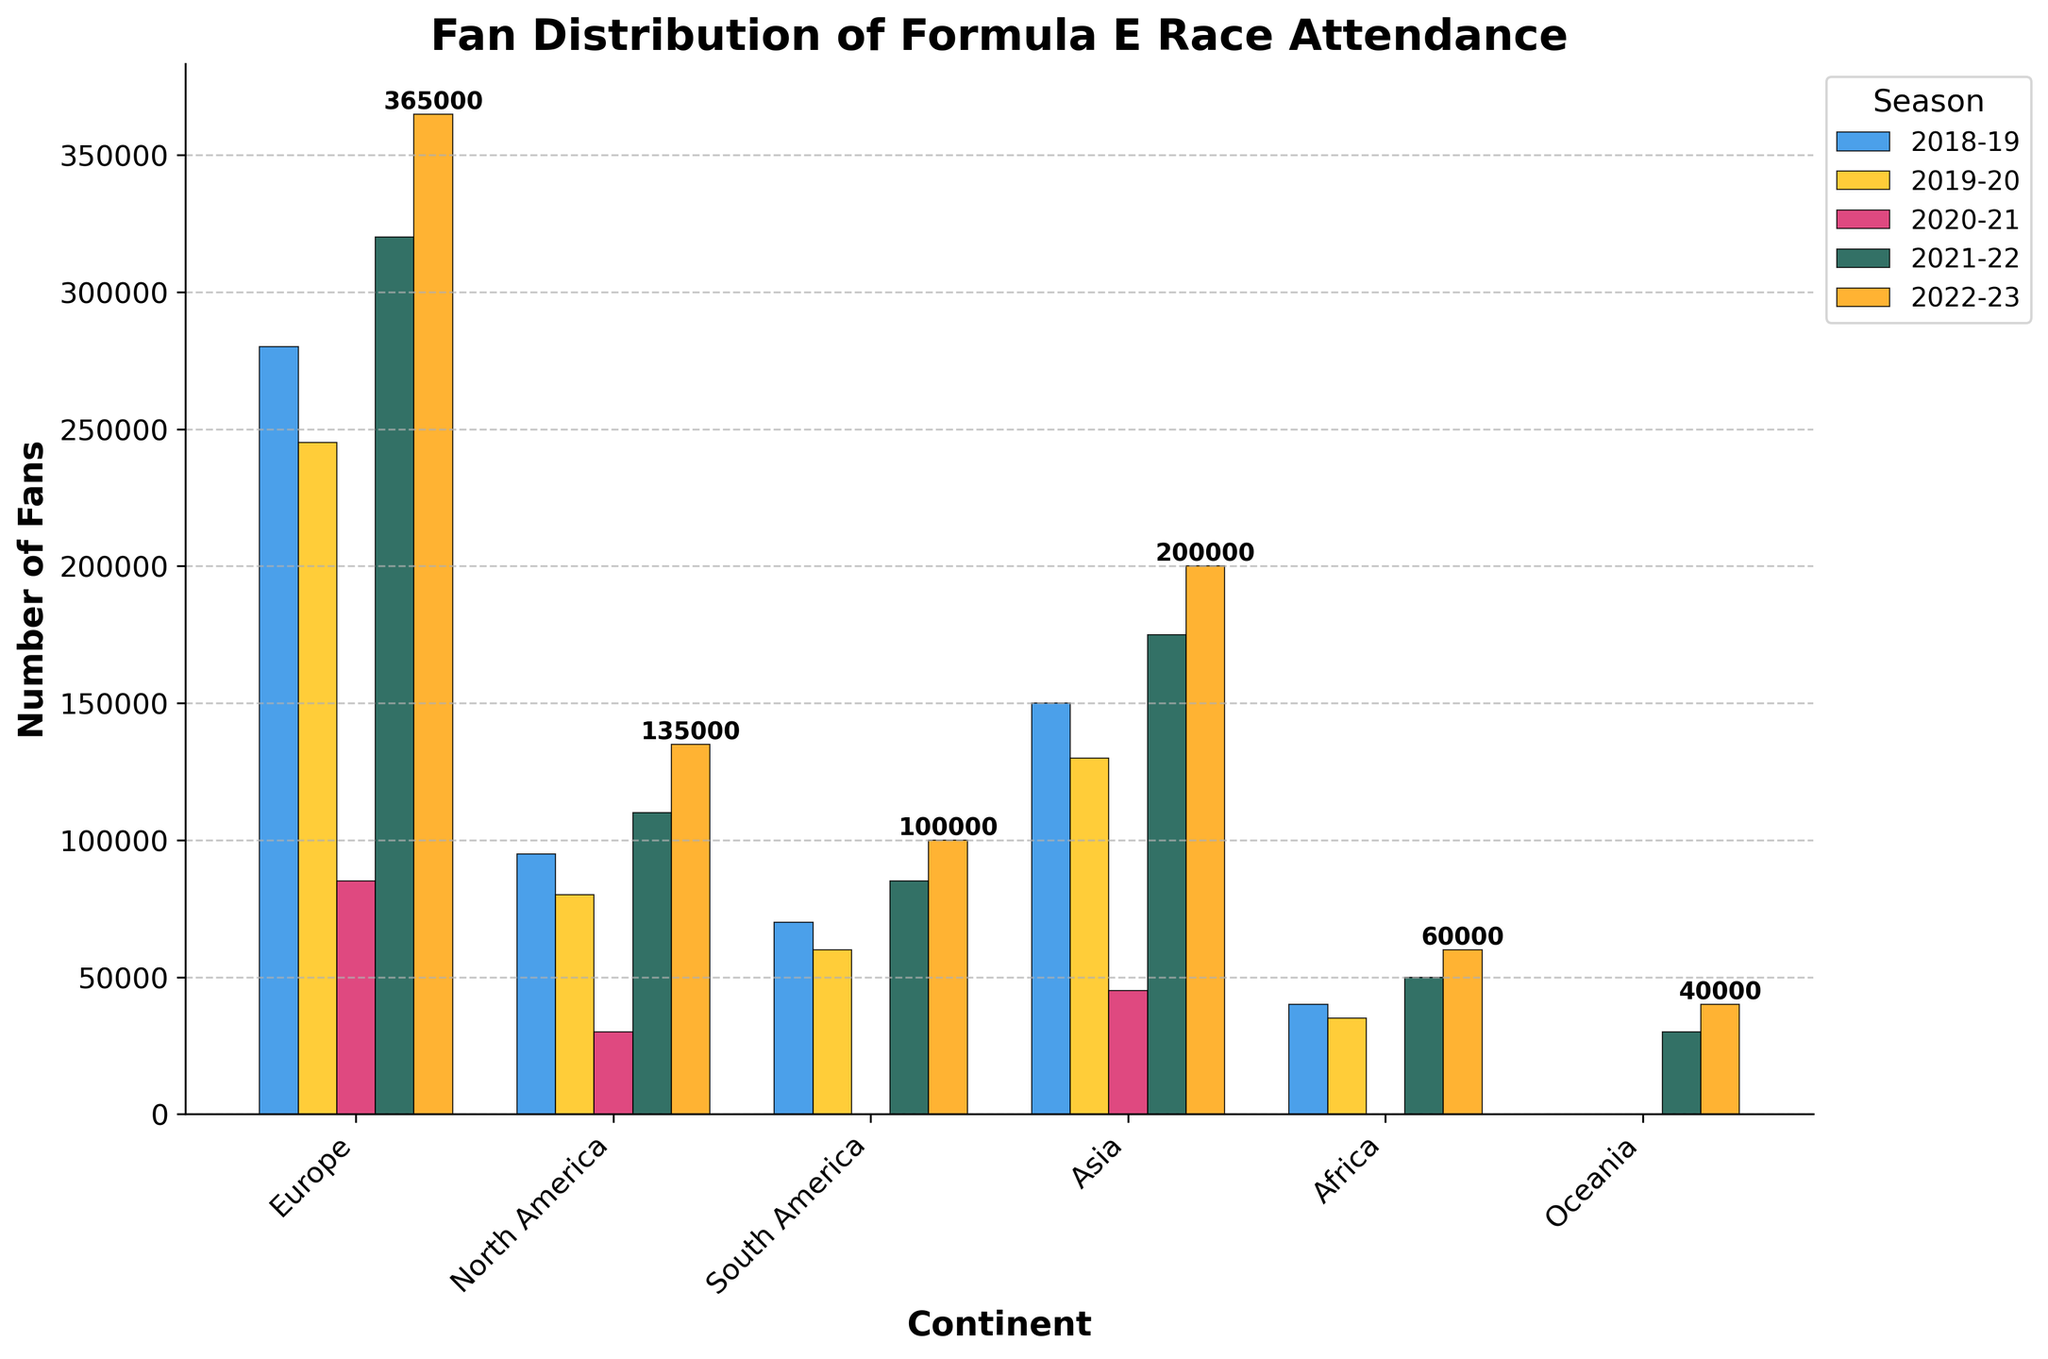What is the title of the chart? The title of the chart is located at the top of the figure. It reads "Fan Distribution of Formula E Race Attendance".
Answer: Fan Distribution of Formula E Race Attendance Which continent had zero fans in the 2020-21 season? By examining the bars for the 2020-21 season, it is evident that South America, Africa, and Oceania have bars representing zero fans.
Answer: South America, Africa, Oceania What is the total number of fans attending races in Europe over the past 5 seasons? To get the total, sum the number of fans for Europe over the seasons: 280000 + 245000 + 85000 + 320000 + 365000 = 1295000.
Answer: 1295000 Which continent witnessed the largest increase in fan attendance from the 2021-22 season to the 2022-23 season? Calculate the difference for each continent: 
Europe: 365000 - 320000 = 45000
North America: 135000 - 110000 = 25000
South America: 100000 - 85000 = 15000
Asia: 200000 - 175000 = 25000
Africa: 60000 - 50000 = 10000
Oceania: 40000 - 30000 = 10000
The largest increase is seen in Europe with 45000 more fans.
Answer: Europe In which season did North America experience the lowest fan attendance? By observing the heights of the bars for North America, the lowest fan attendance is in the 2020-21 season.
Answer: 2020-21 How did the fan attendance in Asia compare between the 2018-19 and 2020-21 seasons? Compare the heights of the bars for Asia: 
2018-19: 150000
2020-21: 45000
There was a decrease of 150000 - 45000 = 105000 fans.
Answer: Decreased by 105000 Which continent had no fan attendance before the 2021-22 season? Oceania had no fan attendance before the 2021-22 season, indicated by the zero bars in previous seasons.
Answer: Oceania What is the trend of fan attendance in Europe from 2018-19 to 2022-23? Observing the heights of the bars for Europe over the seasons, the trend is: 
280000 (2018-19) -> 245000 (2019-20) -> 85000 (2020-21) -> 320000 (2021-22) -> 365000 (2022-23).
There is an initial decrease from 2018-19 to 2020-21, followed by a significant increase from 2020-21 to 2022-23.
Answer: Decrease then increase What is the average number of fans for Africa over the five seasons? To find the average, sum the fans for Africa and divide by the number of seasons: 
(40000 + 35000 + 0 + 50000 + 60000) / 5 = 185000 / 5 = 37000.
Answer: 37000 